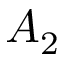<formula> <loc_0><loc_0><loc_500><loc_500>A _ { 2 }</formula> 